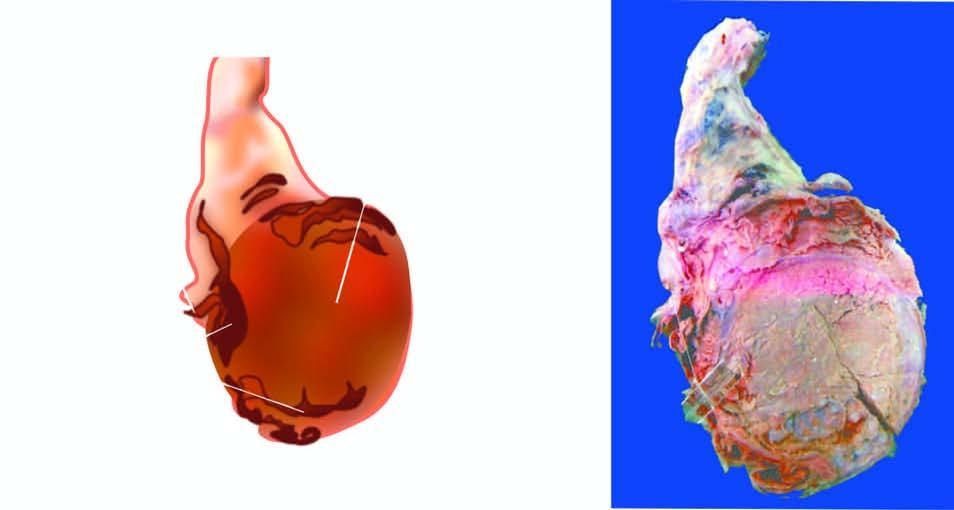s infarcted area enlarged and nodular distorting the testicular contour?
Answer the question using a single word or phrase. No 